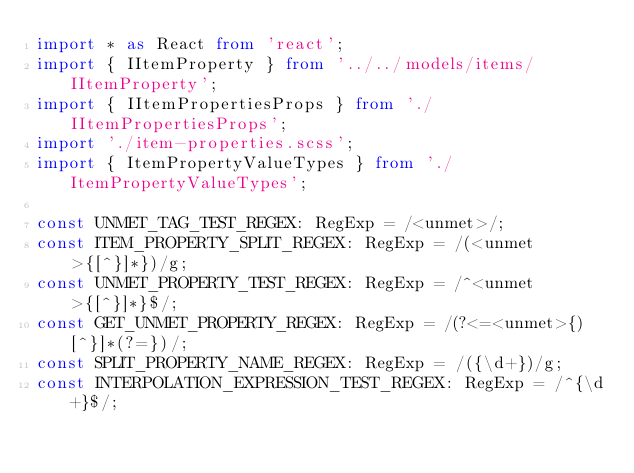<code> <loc_0><loc_0><loc_500><loc_500><_TypeScript_>import * as React from 'react';
import { IItemProperty } from '../../models/items/IItemProperty';
import { IItemPropertiesProps } from './IItemPropertiesProps';
import './item-properties.scss';
import { ItemPropertyValueTypes } from './ItemPropertyValueTypes';

const UNMET_TAG_TEST_REGEX: RegExp = /<unmet>/;
const ITEM_PROPERTY_SPLIT_REGEX: RegExp = /(<unmet>{[^}]*})/g;
const UNMET_PROPERTY_TEST_REGEX: RegExp = /^<unmet>{[^}]*}$/;
const GET_UNMET_PROPERTY_REGEX: RegExp = /(?<=<unmet>{)[^}]*(?=})/;
const SPLIT_PROPERTY_NAME_REGEX: RegExp = /({\d+})/g;
const INTERPOLATION_EXPRESSION_TEST_REGEX: RegExp = /^{\d+}$/;</code> 